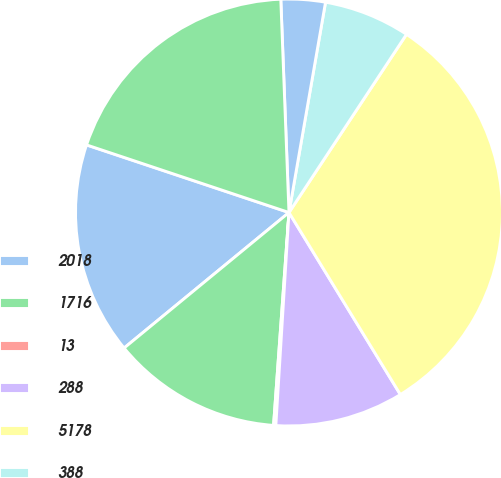<chart> <loc_0><loc_0><loc_500><loc_500><pie_chart><fcel>2018<fcel>1716<fcel>13<fcel>288<fcel>5178<fcel>388<fcel>123<fcel>2354<nl><fcel>16.08%<fcel>12.9%<fcel>0.17%<fcel>9.72%<fcel>31.98%<fcel>6.54%<fcel>3.35%<fcel>19.26%<nl></chart> 